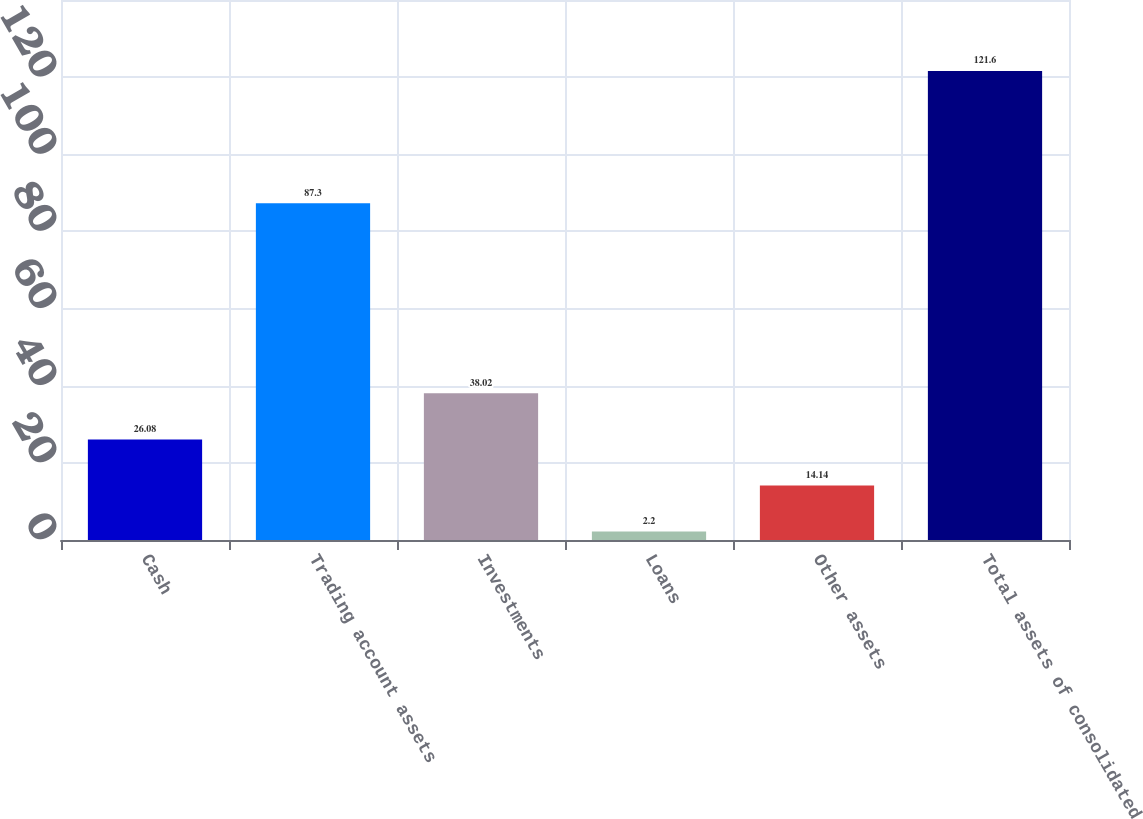Convert chart to OTSL. <chart><loc_0><loc_0><loc_500><loc_500><bar_chart><fcel>Cash<fcel>Trading account assets<fcel>Investments<fcel>Loans<fcel>Other assets<fcel>Total assets of consolidated<nl><fcel>26.08<fcel>87.3<fcel>38.02<fcel>2.2<fcel>14.14<fcel>121.6<nl></chart> 